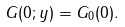Convert formula to latex. <formula><loc_0><loc_0><loc_500><loc_500>G ( 0 ; y ) = G _ { 0 } ( 0 ) .</formula> 